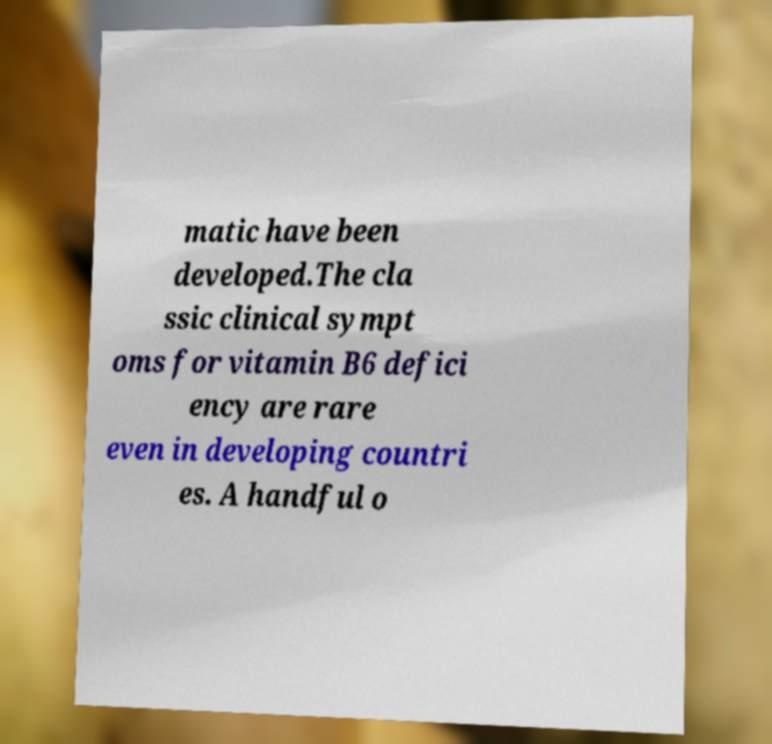What messages or text are displayed in this image? I need them in a readable, typed format. matic have been developed.The cla ssic clinical sympt oms for vitamin B6 defici ency are rare even in developing countri es. A handful o 